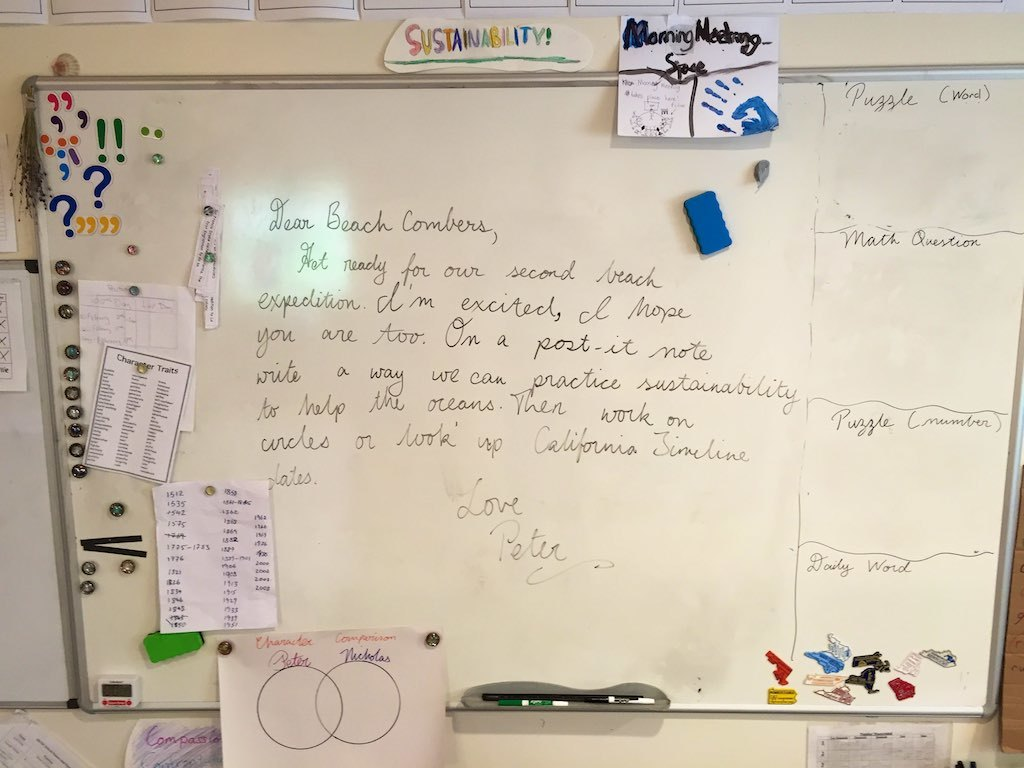Can you tell me more about the significance of the circles on this whiteboard? Certainly! The two circles drawn on the whiteboard, labelled 'Petra' and 'Nicholas', symbolize the intersection of ideas or contributions between these two individuals. This visual might be used to encourage team members to think about how their efforts overlap and contribute to common goals, such as sustainability projects mentioned on the board. 